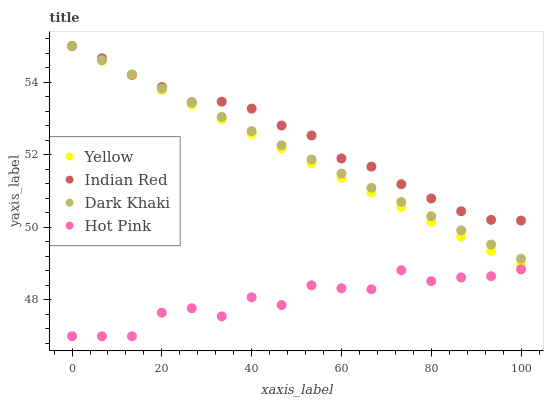Does Hot Pink have the minimum area under the curve?
Answer yes or no. Yes. Does Indian Red have the maximum area under the curve?
Answer yes or no. Yes. Does Indian Red have the minimum area under the curve?
Answer yes or no. No. Does Hot Pink have the maximum area under the curve?
Answer yes or no. No. Is Dark Khaki the smoothest?
Answer yes or no. Yes. Is Hot Pink the roughest?
Answer yes or no. Yes. Is Indian Red the smoothest?
Answer yes or no. No. Is Indian Red the roughest?
Answer yes or no. No. Does Hot Pink have the lowest value?
Answer yes or no. Yes. Does Indian Red have the lowest value?
Answer yes or no. No. Does Yellow have the highest value?
Answer yes or no. Yes. Does Hot Pink have the highest value?
Answer yes or no. No. Is Hot Pink less than Indian Red?
Answer yes or no. Yes. Is Indian Red greater than Hot Pink?
Answer yes or no. Yes. Does Dark Khaki intersect Indian Red?
Answer yes or no. Yes. Is Dark Khaki less than Indian Red?
Answer yes or no. No. Is Dark Khaki greater than Indian Red?
Answer yes or no. No. Does Hot Pink intersect Indian Red?
Answer yes or no. No. 